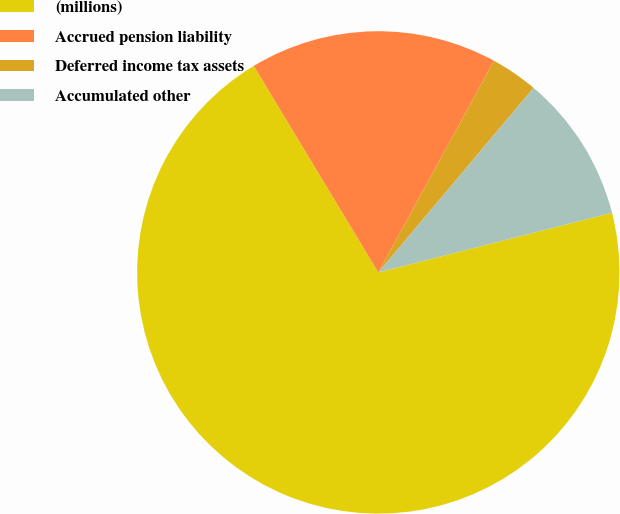<chart> <loc_0><loc_0><loc_500><loc_500><pie_chart><fcel>(millions)<fcel>Accrued pension liability<fcel>Deferred income tax assets<fcel>Accumulated other<nl><fcel>70.34%<fcel>16.6%<fcel>3.17%<fcel>9.89%<nl></chart> 